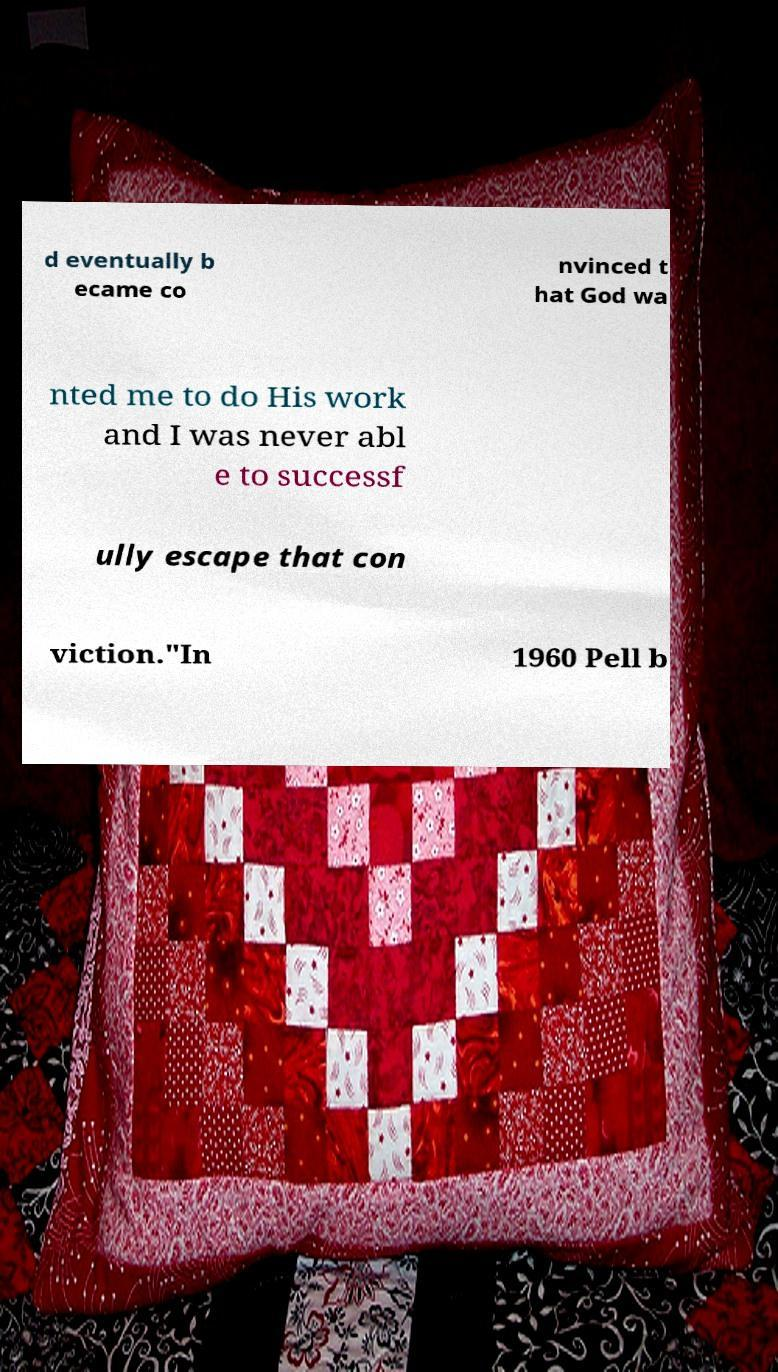I need the written content from this picture converted into text. Can you do that? d eventually b ecame co nvinced t hat God wa nted me to do His work and I was never abl e to successf ully escape that con viction."In 1960 Pell b 